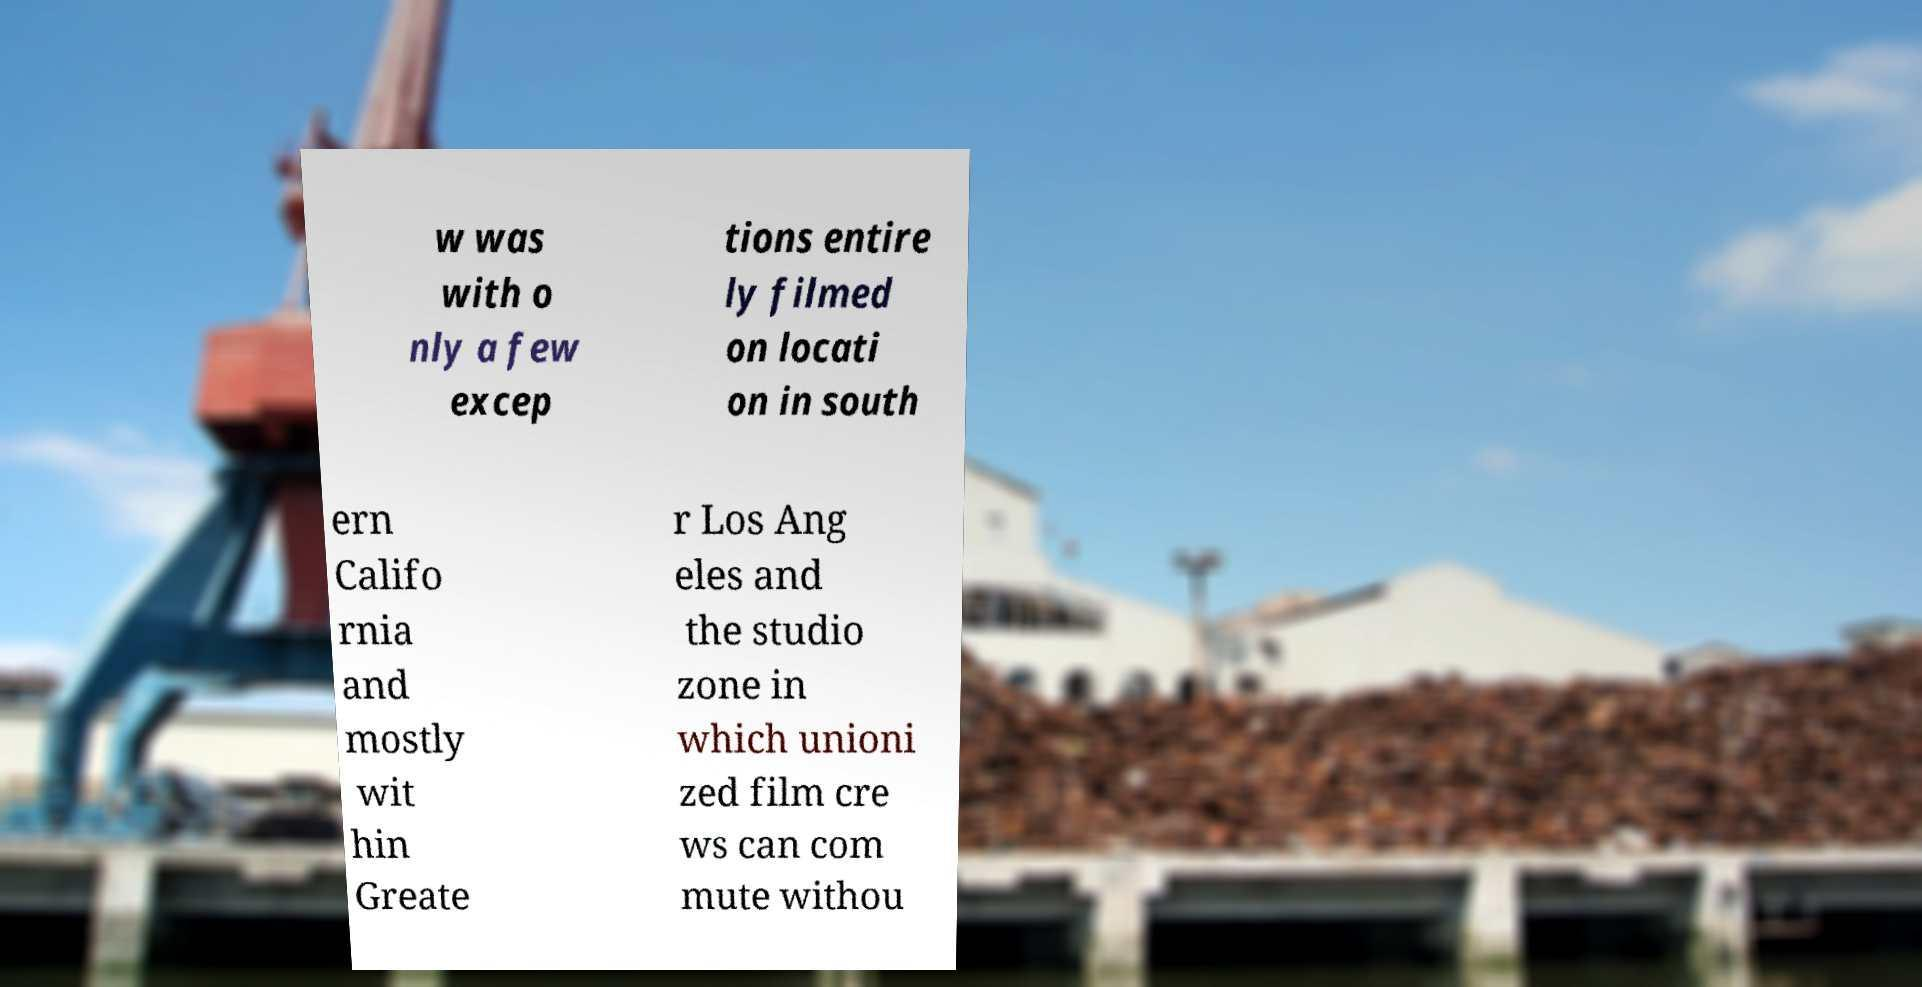For documentation purposes, I need the text within this image transcribed. Could you provide that? w was with o nly a few excep tions entire ly filmed on locati on in south ern Califo rnia and mostly wit hin Greate r Los Ang eles and the studio zone in which unioni zed film cre ws can com mute withou 